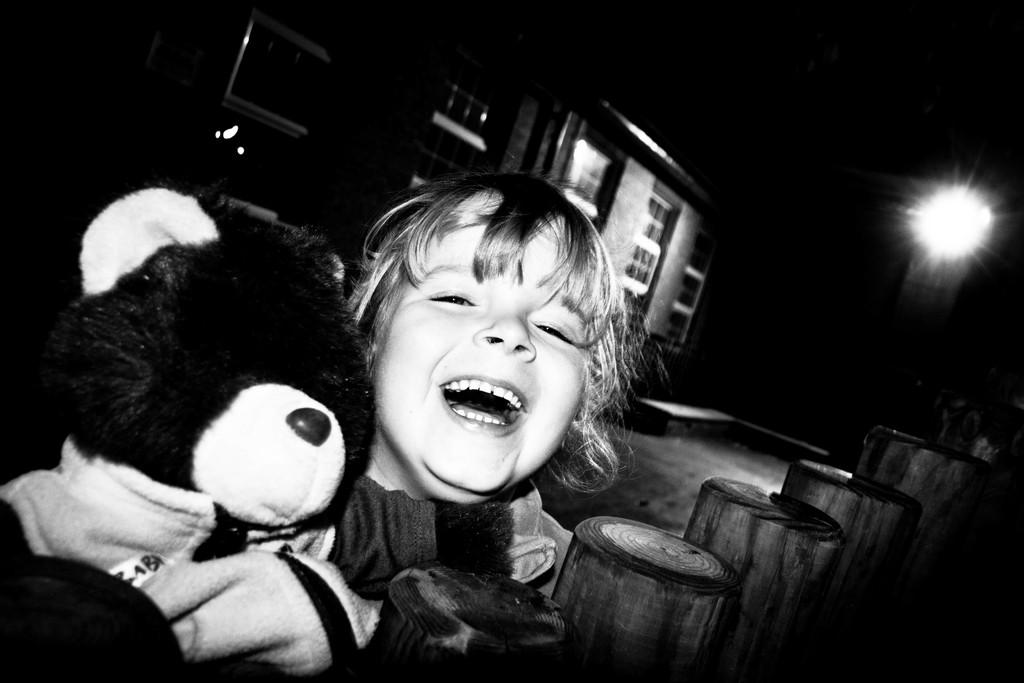What is the main subject of the picture? The main subject of the picture is a child. What is the child holding in the picture? The child is holding a doll. What is the child doing in the picture? The child is coughing. What can be seen in the background of the picture? There is a building with windows in the background. What is the source of light in the image? There is a light visible in the image. Does the child's sister appear in the image? There is no mention of a sister in the provided facts, and therefore it cannot be determined if the child has a sister or if she appears in the image. 